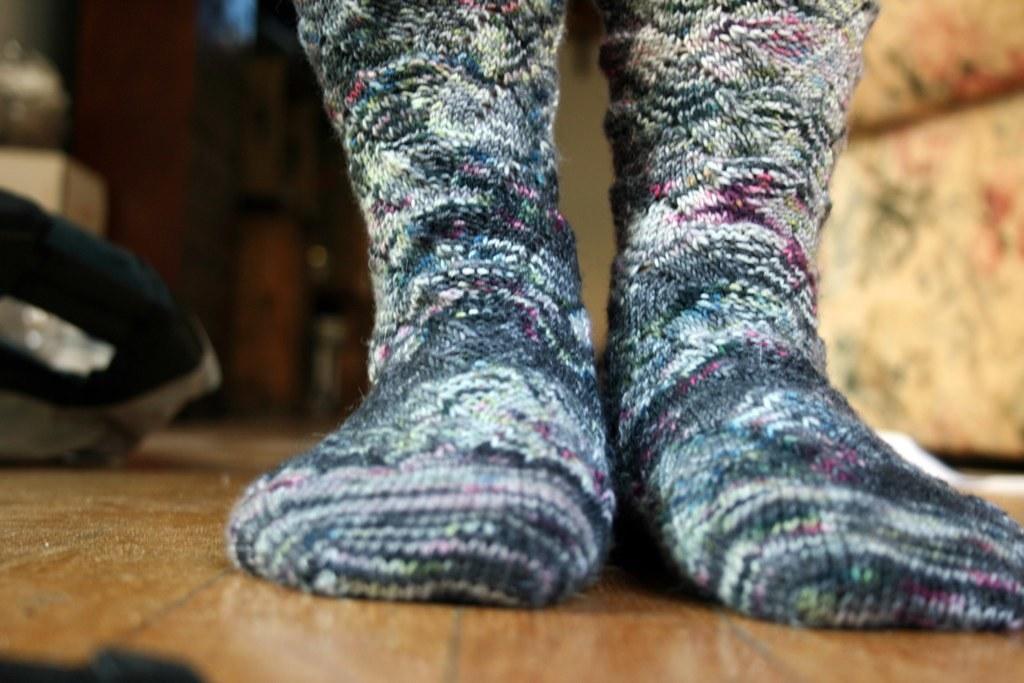Describe this image in one or two sentences. In this picture I can see there are two socks in black and white color. At the bottom it is the floor. 